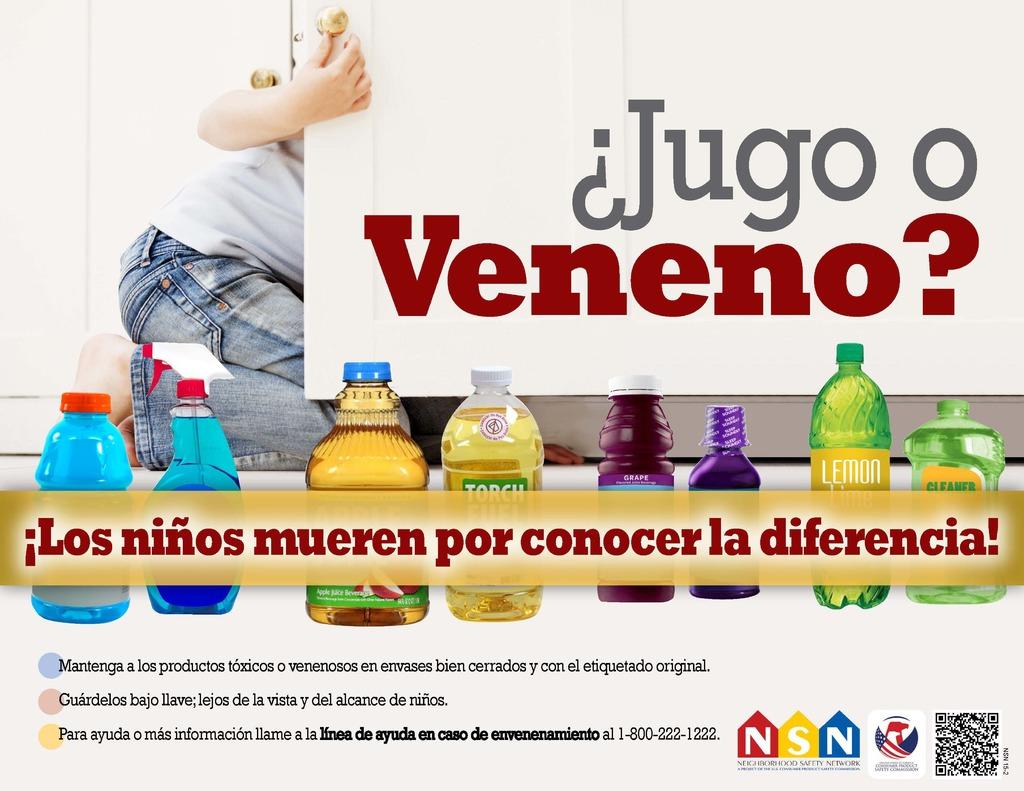What is the phone number listed?
Offer a very short reply. 1-800-222-1222. What question is being asked at the top of the page?
Offer a very short reply. Jugo o veneno?. 